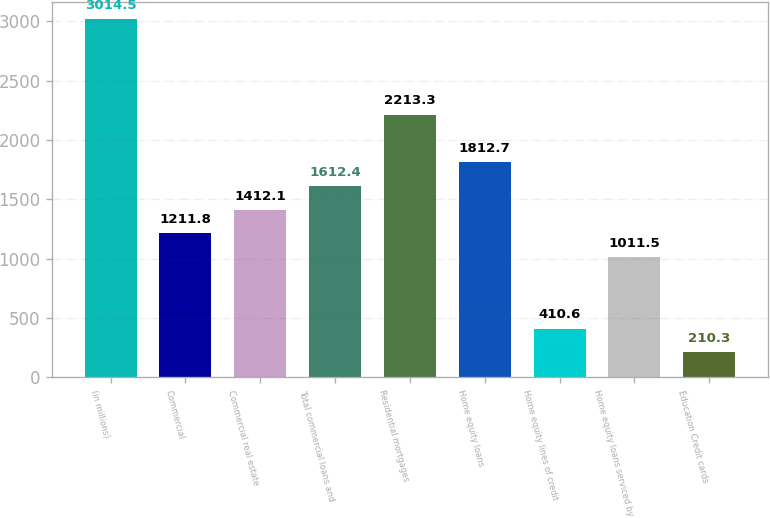<chart> <loc_0><loc_0><loc_500><loc_500><bar_chart><fcel>(in millions)<fcel>Commercial<fcel>Commercial real estate<fcel>Total commercial loans and<fcel>Residential mortgages<fcel>Home equity loans<fcel>Home equity lines of credit<fcel>Home equity loans serviced by<fcel>Education Credit cards<nl><fcel>3014.5<fcel>1211.8<fcel>1412.1<fcel>1612.4<fcel>2213.3<fcel>1812.7<fcel>410.6<fcel>1011.5<fcel>210.3<nl></chart> 